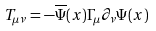Convert formula to latex. <formula><loc_0><loc_0><loc_500><loc_500>T _ { \mu \nu } = - \overline { \Psi } ( x ) \Gamma _ { \mu } \partial _ { \nu } \Psi ( x )</formula> 